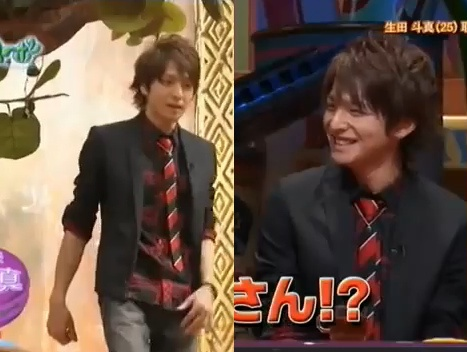Describe the objects in this image and their specific colors. I can see people in black, maroon, brown, and red tones, people in black, maroon, brown, and gray tones, tie in black, maroon, brown, and gray tones, and tie in black, maroon, and brown tones in this image. 